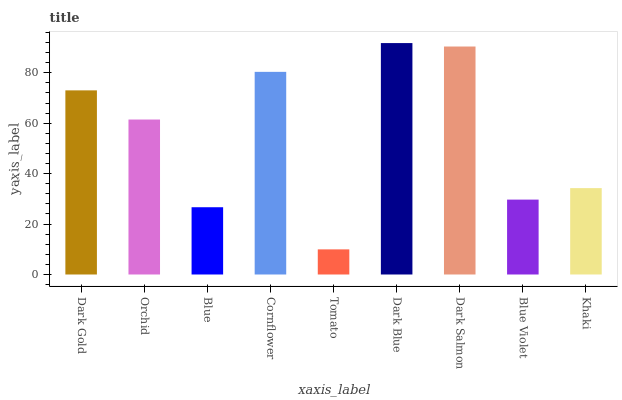Is Tomato the minimum?
Answer yes or no. Yes. Is Dark Blue the maximum?
Answer yes or no. Yes. Is Orchid the minimum?
Answer yes or no. No. Is Orchid the maximum?
Answer yes or no. No. Is Dark Gold greater than Orchid?
Answer yes or no. Yes. Is Orchid less than Dark Gold?
Answer yes or no. Yes. Is Orchid greater than Dark Gold?
Answer yes or no. No. Is Dark Gold less than Orchid?
Answer yes or no. No. Is Orchid the high median?
Answer yes or no. Yes. Is Orchid the low median?
Answer yes or no. Yes. Is Dark Gold the high median?
Answer yes or no. No. Is Tomato the low median?
Answer yes or no. No. 